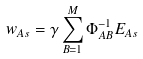<formula> <loc_0><loc_0><loc_500><loc_500>w _ { A s } = \gamma \sum _ { B = 1 } ^ { M } \Phi _ { A B } ^ { - 1 } E _ { A s }</formula> 